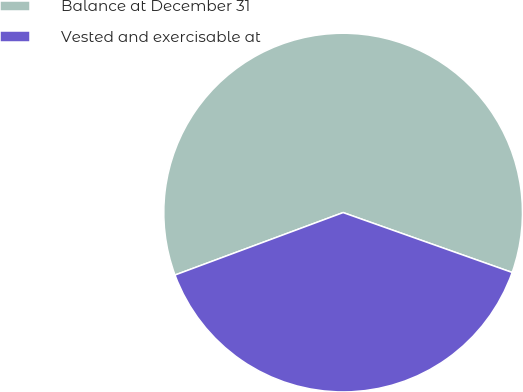Convert chart. <chart><loc_0><loc_0><loc_500><loc_500><pie_chart><fcel>Balance at December 31<fcel>Vested and exercisable at<nl><fcel>61.08%<fcel>38.92%<nl></chart> 